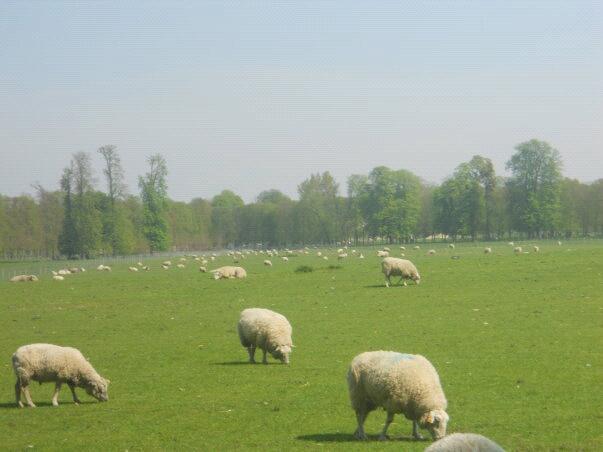Can the sheep roam freely?
Write a very short answer. Yes. What are the sheep eating?
Give a very brief answer. Grass. Are there more than 56 sheep?
Give a very brief answer. Yes. What is in the background of the picture?
Be succinct. Trees. 